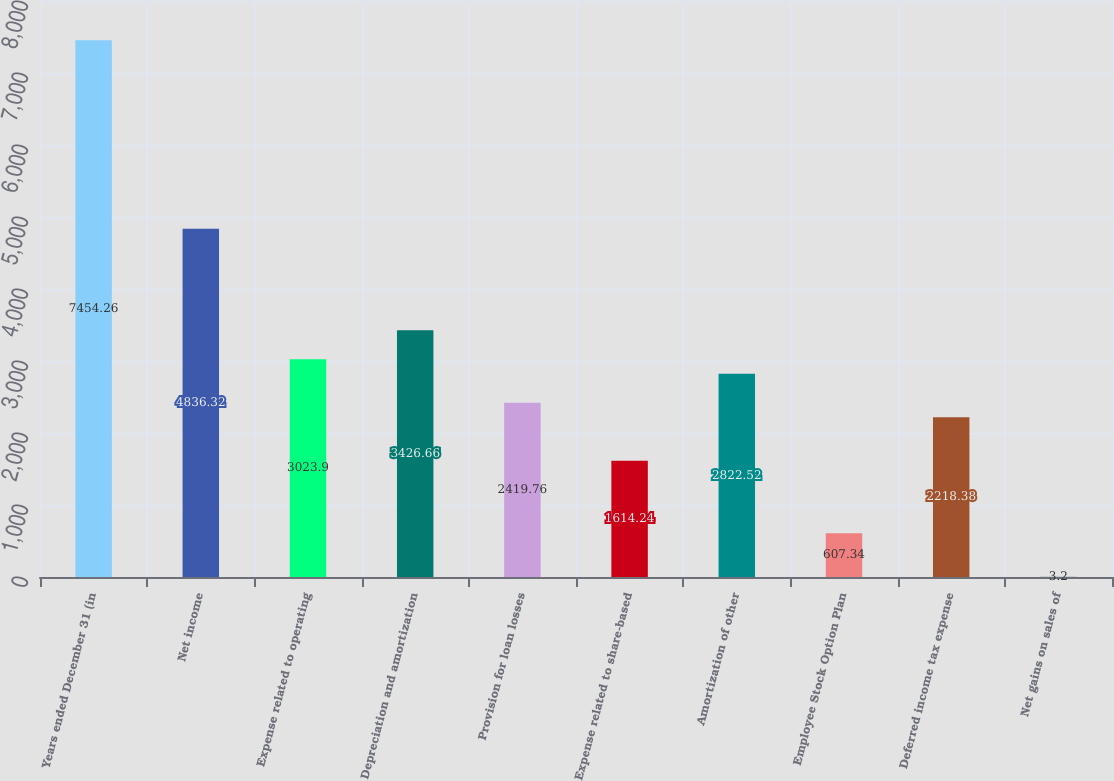<chart> <loc_0><loc_0><loc_500><loc_500><bar_chart><fcel>Years ended December 31 (in<fcel>Net income<fcel>Expense related to operating<fcel>Depreciation and amortization<fcel>Provision for loan losses<fcel>Expense related to share-based<fcel>Amortization of other<fcel>Employee Stock Option Plan<fcel>Deferred income tax expense<fcel>Net gains on sales of<nl><fcel>7454.26<fcel>4836.32<fcel>3023.9<fcel>3426.66<fcel>2419.76<fcel>1614.24<fcel>2822.52<fcel>607.34<fcel>2218.38<fcel>3.2<nl></chart> 